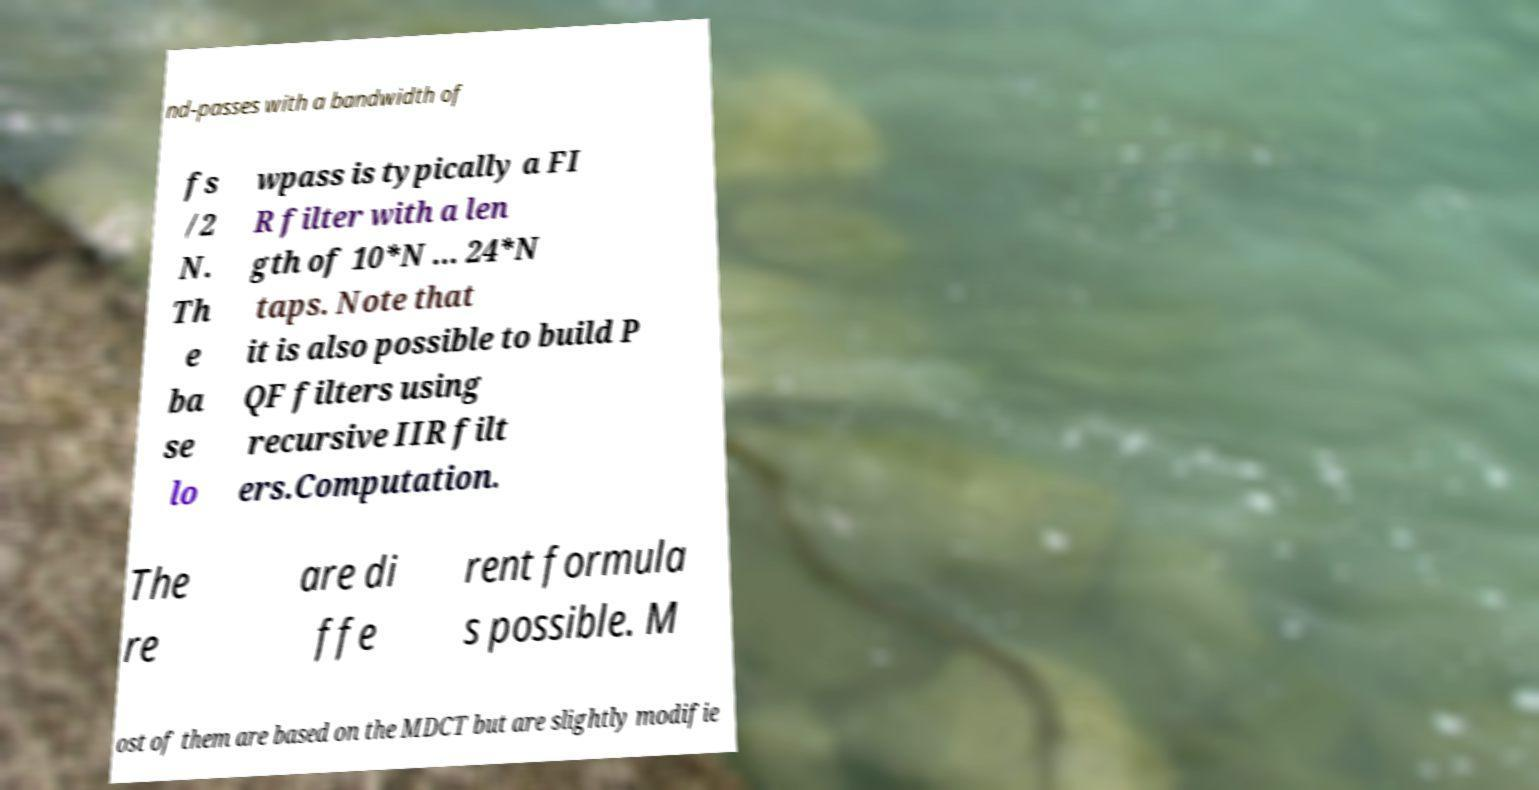Please identify and transcribe the text found in this image. nd-passes with a bandwidth of fs /2 N. Th e ba se lo wpass is typically a FI R filter with a len gth of 10*N ... 24*N taps. Note that it is also possible to build P QF filters using recursive IIR filt ers.Computation. The re are di ffe rent formula s possible. M ost of them are based on the MDCT but are slightly modifie 